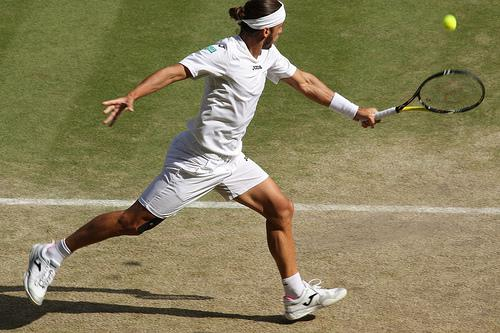Question: what kind of shoes is the man wearing?
Choices:
A. Boots.
B. Flip flops.
C. Tennis shoes.
D. Sandals.
Answer with the letter. Answer: C Question: how many people are in this photo?
Choices:
A. 3.
B. 1.
C. 4.
D. 5.
Answer with the letter. Answer: B Question: who is running in this photo?
Choices:
A. A dog.
B. A horse.
C. A cow.
D. A man.
Answer with the letter. Answer: D Question: when will the player put the racket down?
Choices:
A. When he wins.
B. After he hits the ball.
C. When the game is finished.
D. To take a break.
Answer with the letter. Answer: B Question: where does this picture take place?
Choices:
A. Baseball field.
B. Basketball court.
C. Tennis court.
D. Beach.
Answer with the letter. Answer: C 